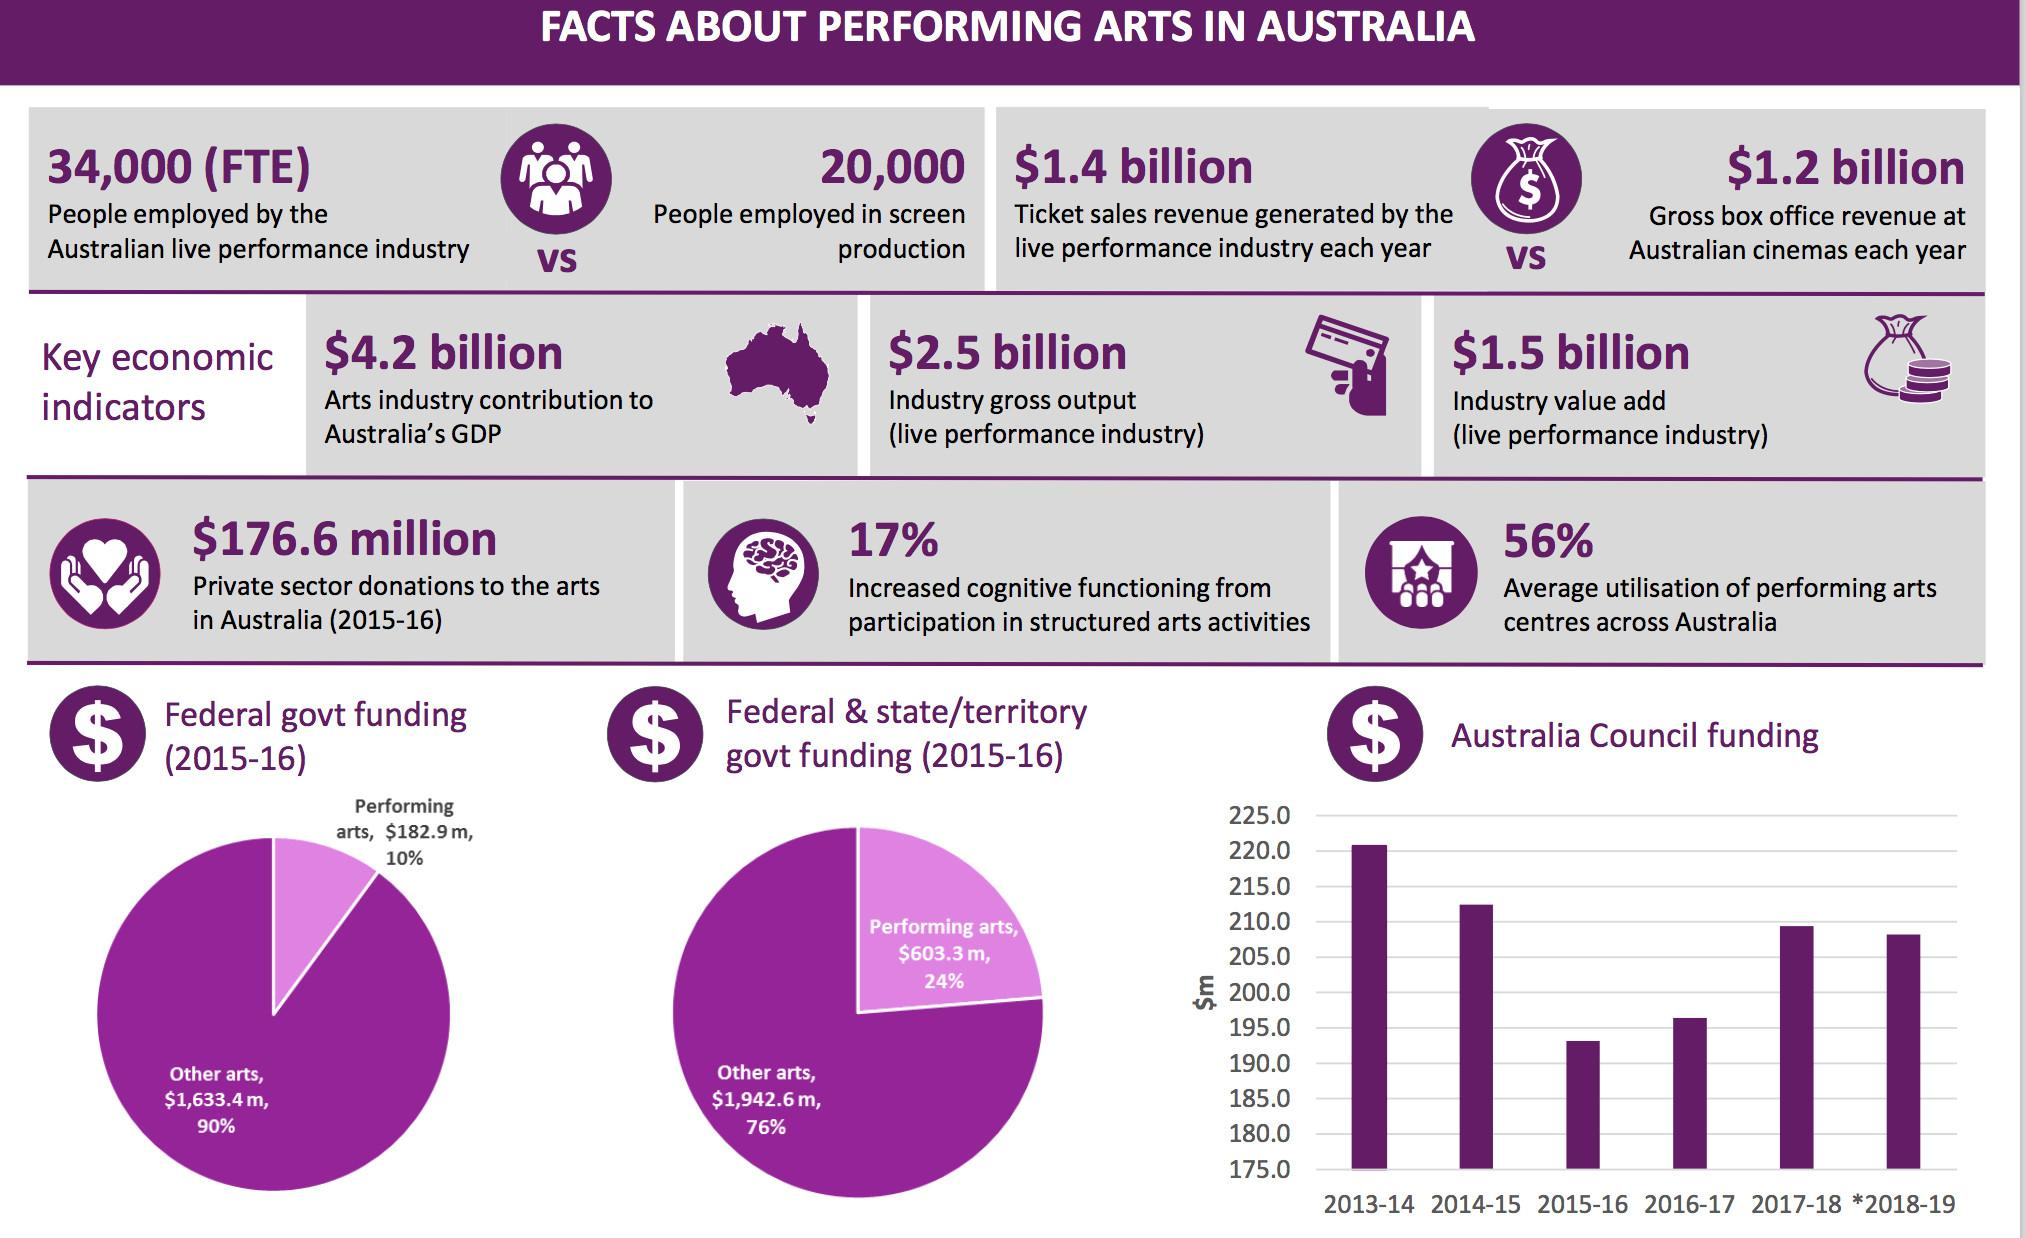Draw attention to some important aspects in this diagram. In the year 2013-14, Australia Council funding was at its highest level. According to a recent survey, nearly half of all performing art centers in Australia are not being utilized to their full capacity. In 2015-16, the Australia Council's funding was below 195 million dollars. 